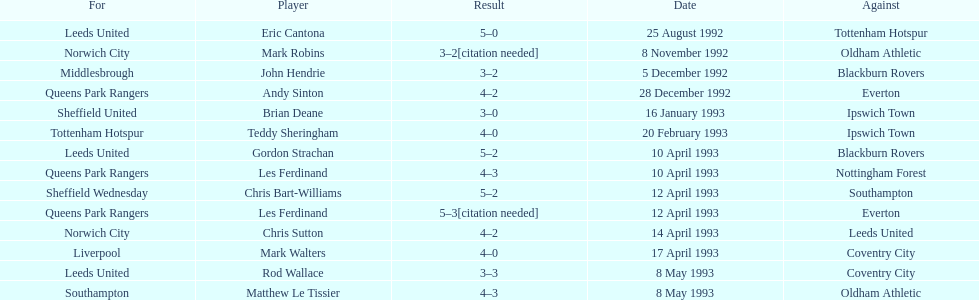What was the result of the match between queens park rangers and everton? 4-2. 